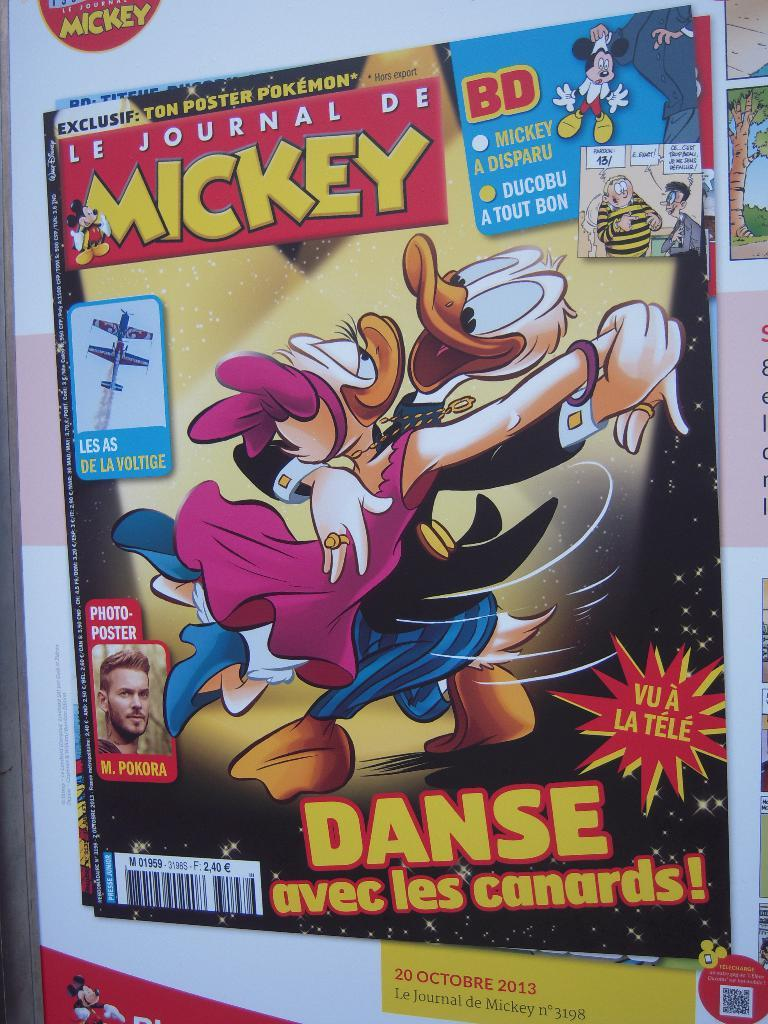What is the main subject of the poster in the image? The poster contains a picture of Mickey Mouse, pictures of ducks, and a picture of an aircraft. What other objects are depicted on the poster? There are various objects depicted on the poster. Are there any identifiers on the poster? Yes, there are barcodes on the poster. What can be seen on the left side of the image? There is a picture of a person on the left side of the image. How does the goose blow the cast in the image? There is no goose or cast present in the image. What type of cast is being blown by the goose in the image? There is no goose or cast present in the image, so this question cannot be answered. 